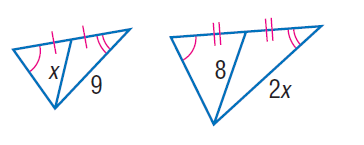Question: Find x.
Choices:
A. 5
B. 6
C. 7
D. 8
Answer with the letter. Answer: B 